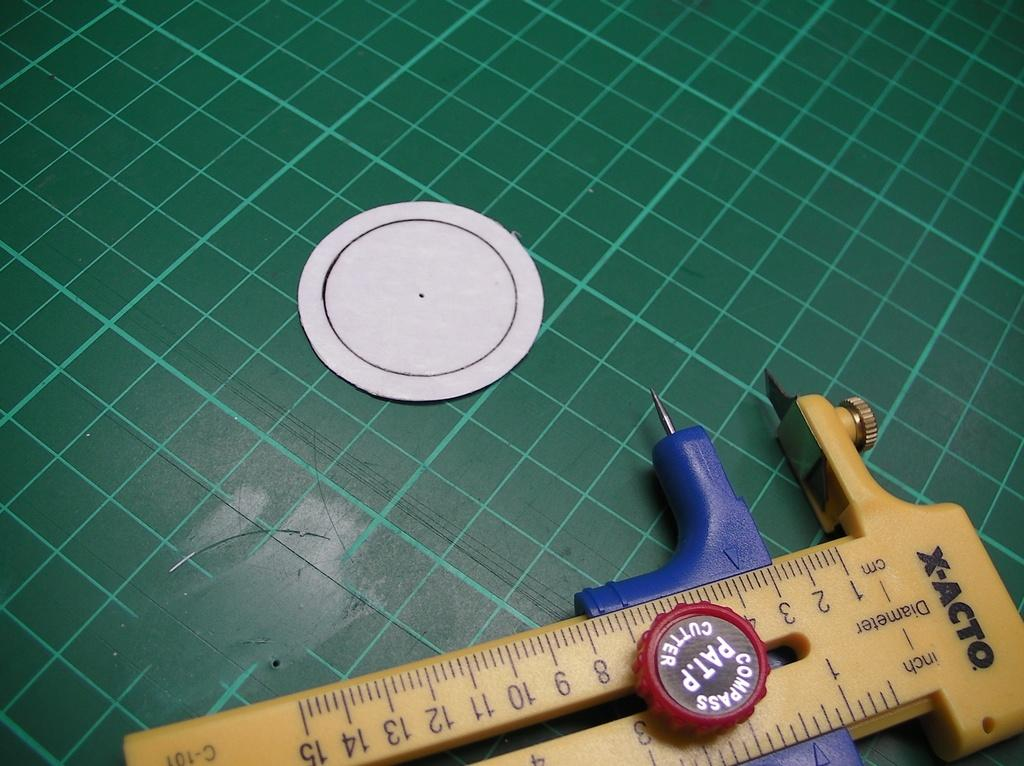<image>
Give a short and clear explanation of the subsequent image. A pair of calipers made by X-acto sits on a green grid mat. 